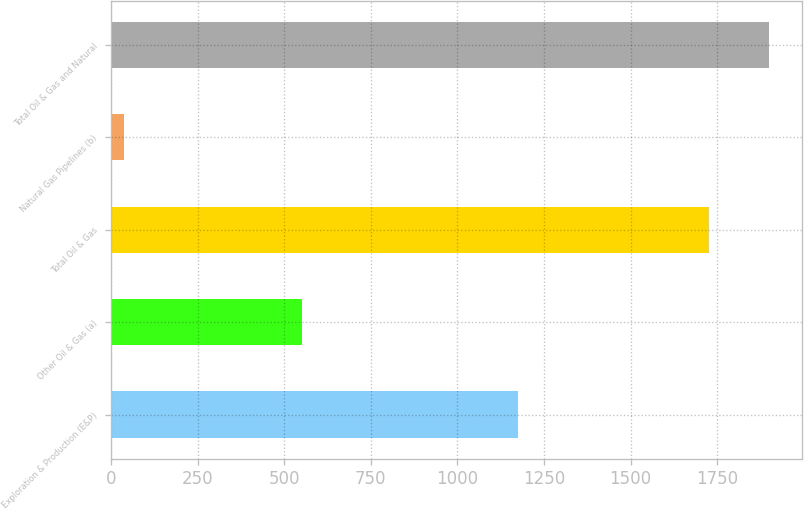Convert chart. <chart><loc_0><loc_0><loc_500><loc_500><bar_chart><fcel>Exploration & Production (E&P)<fcel>Other Oil & Gas (a)<fcel>Total Oil & Gas<fcel>Natural Gas Pipelines (b)<fcel>Total Oil & Gas and Natural<nl><fcel>1175<fcel>552<fcel>1727<fcel>38<fcel>1899.7<nl></chart> 